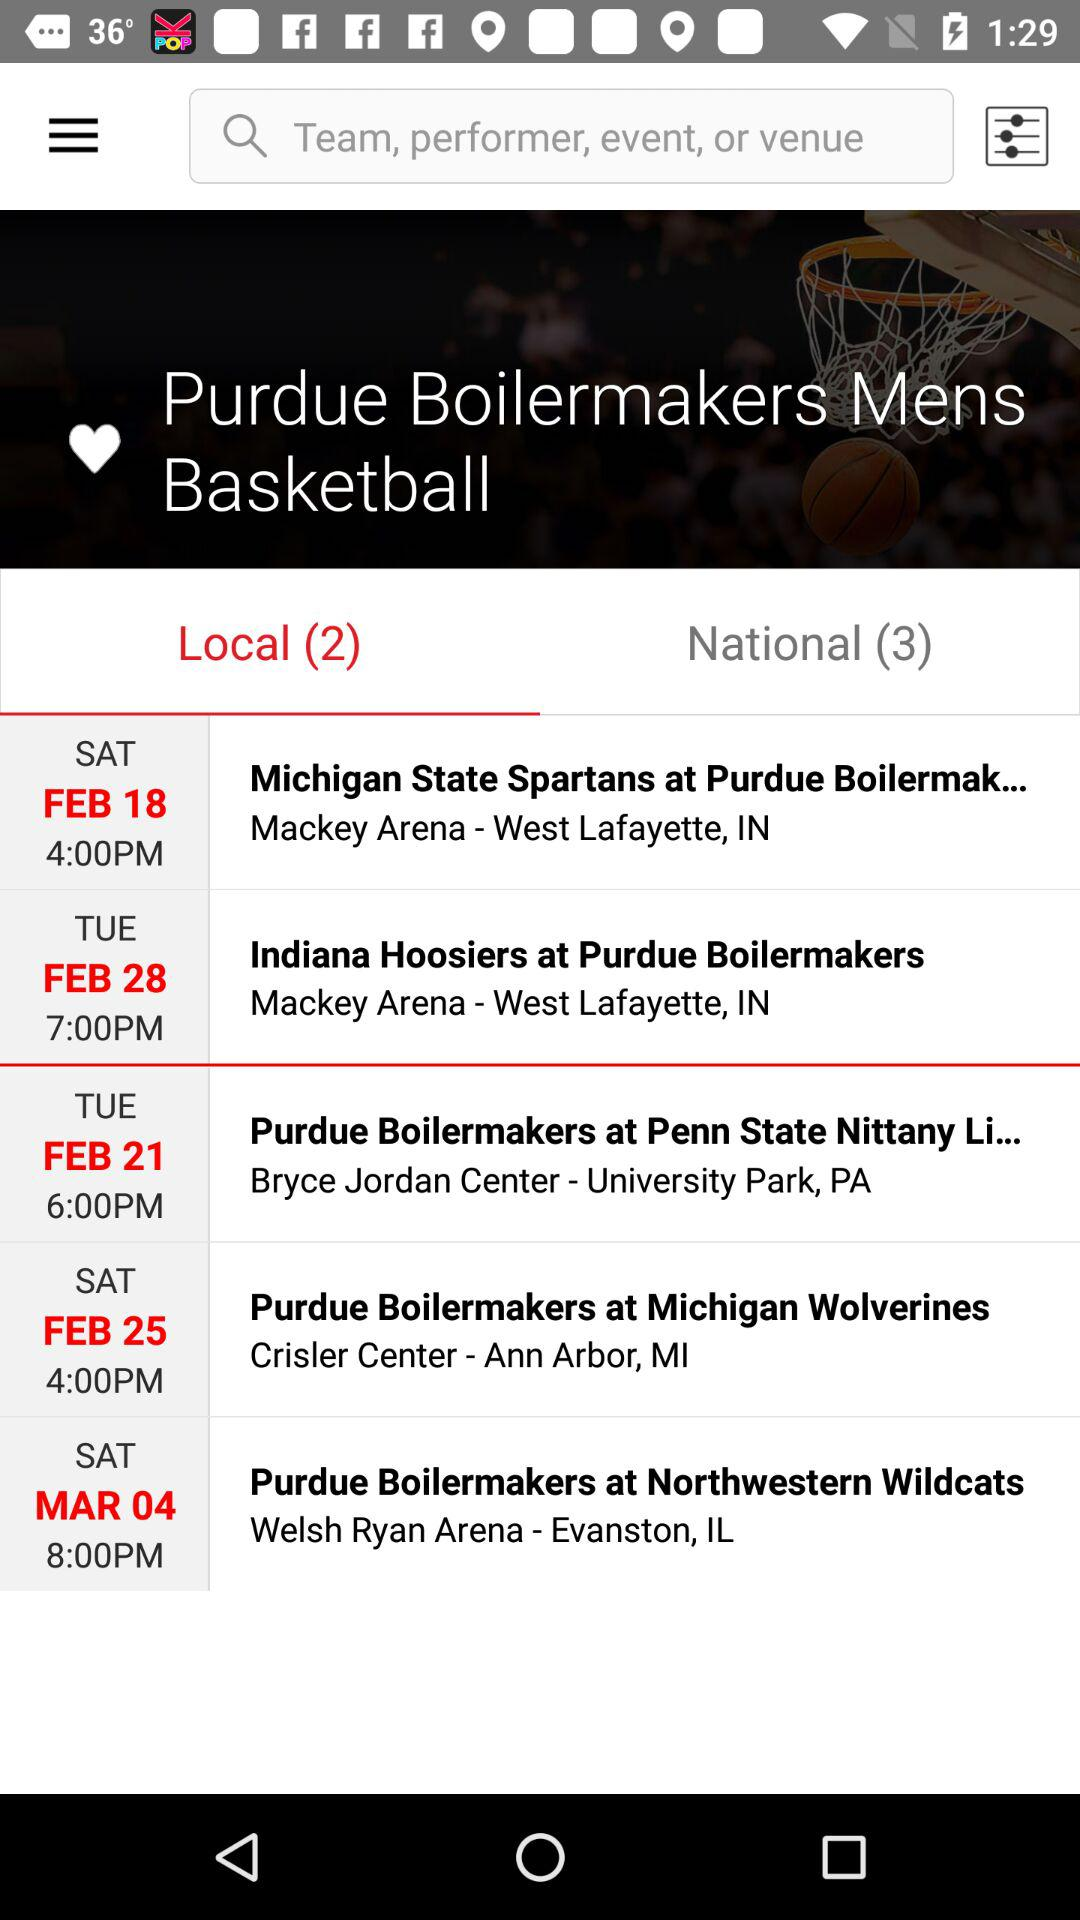How many national matches are there? There are 3 national matches. 